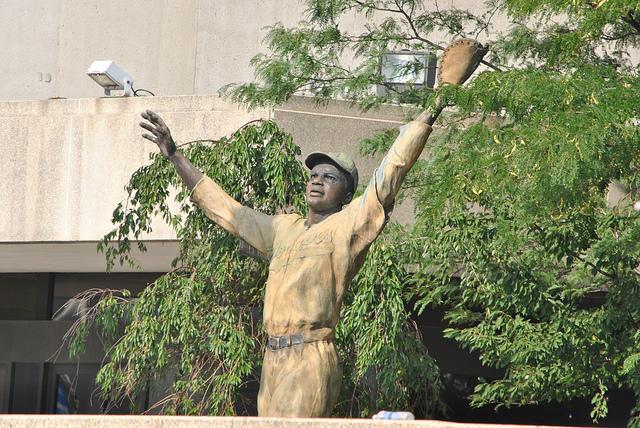What are the different texture of the statue?
Concise answer only. Rough and smooth. Is this a real person?
Keep it brief. No. Is this man at work?
Short answer required. No. 